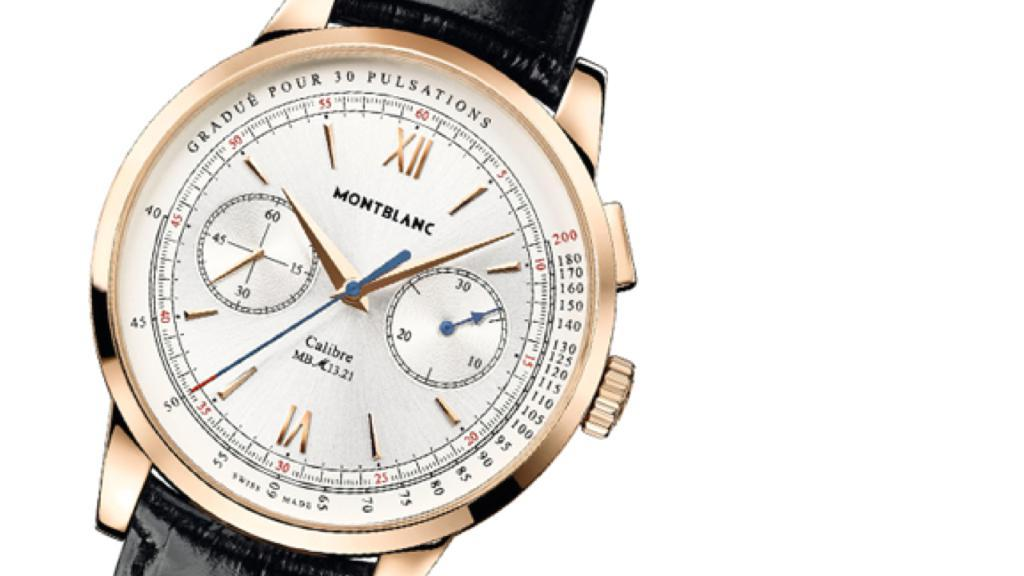<image>
Offer a succinct explanation of the picture presented. the word montblanc that is on a watch 